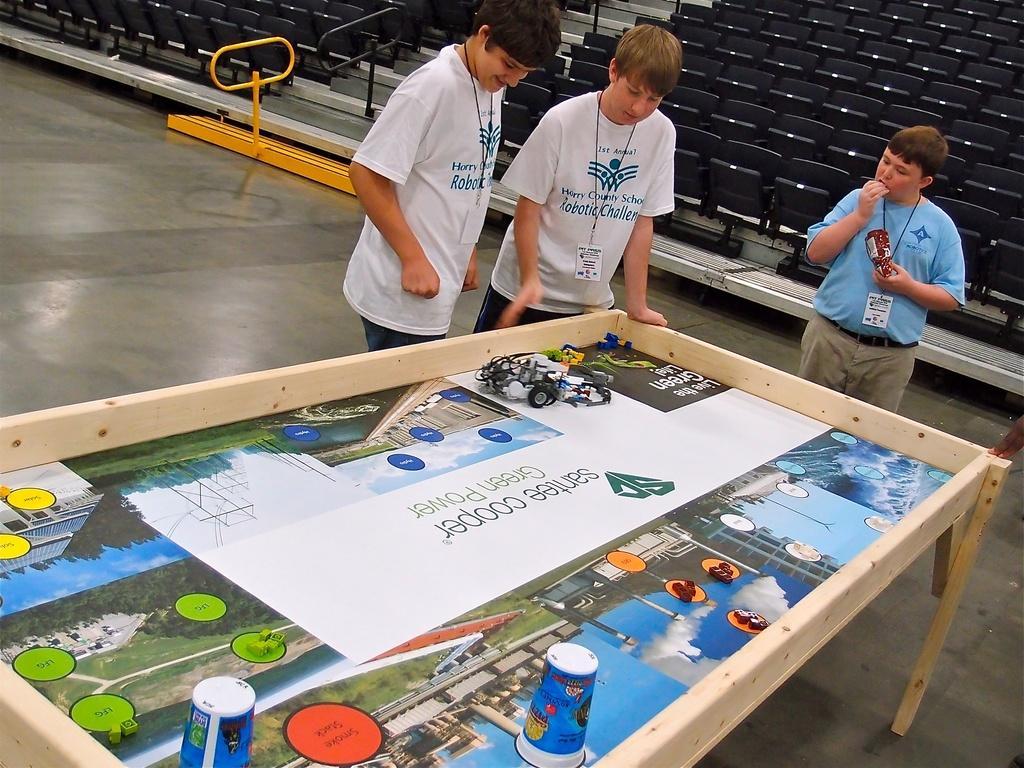Can you describe this image briefly? In this image there are three person. At the back side there are chairs. In front of the person there is a table and some toys. 